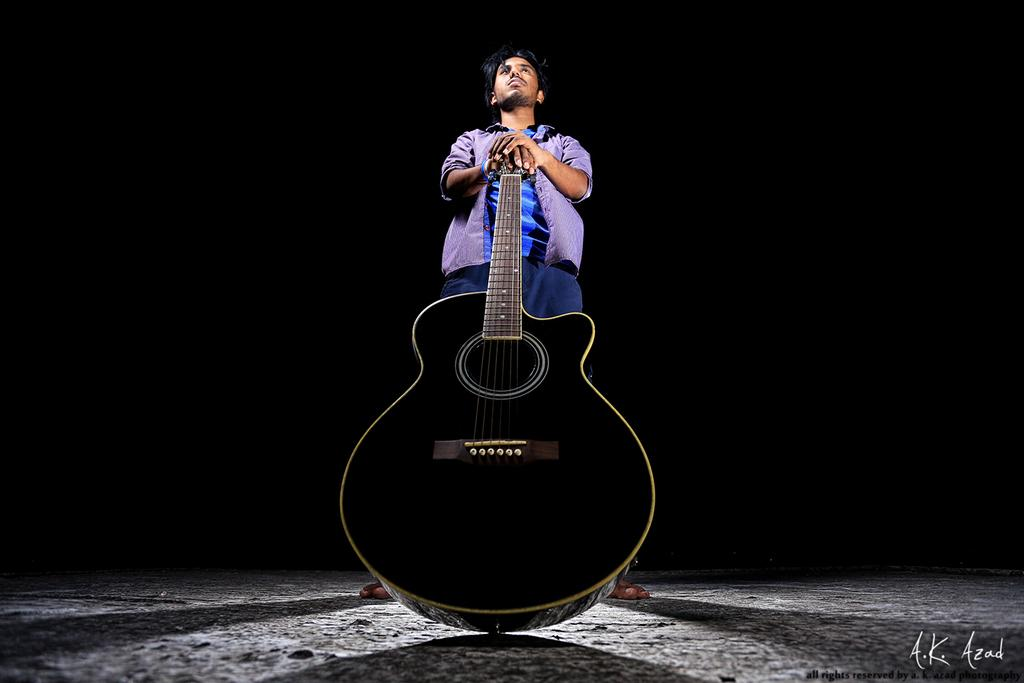What is the main subject of the image? There is a man standing in the middle of the image. What is the man holding in the image? The man is holding a music instrument. What is the color of the music instrument? The music instrument is black in color. What can be seen in the background of the image? The background of the image is black. Can you tell me how many lakes are visible in the image? There are no lakes visible in the image; it features a man holding a black music instrument against a black background. What type of thing is the man using to blow air in the image? There is no indication in the image that the man is blowing air or using any specific thing for that purpose. 